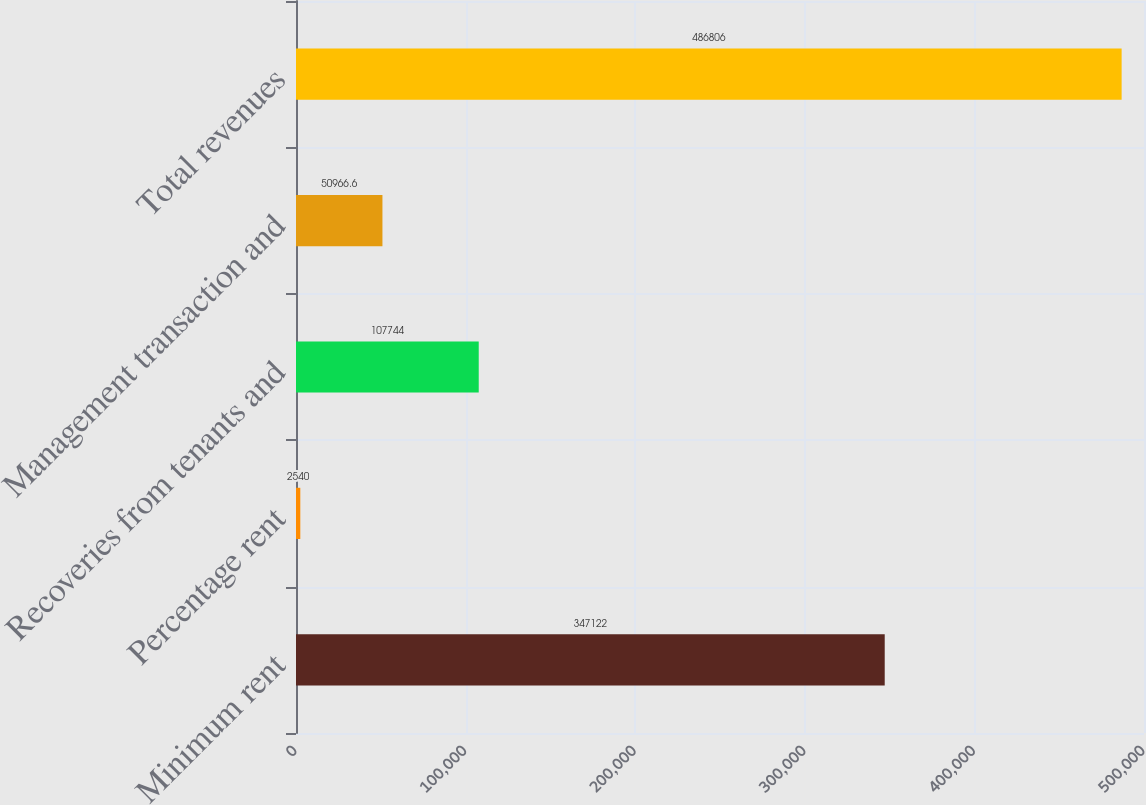Convert chart. <chart><loc_0><loc_0><loc_500><loc_500><bar_chart><fcel>Minimum rent<fcel>Percentage rent<fcel>Recoveries from tenants and<fcel>Management transaction and<fcel>Total revenues<nl><fcel>347122<fcel>2540<fcel>107744<fcel>50966.6<fcel>486806<nl></chart> 